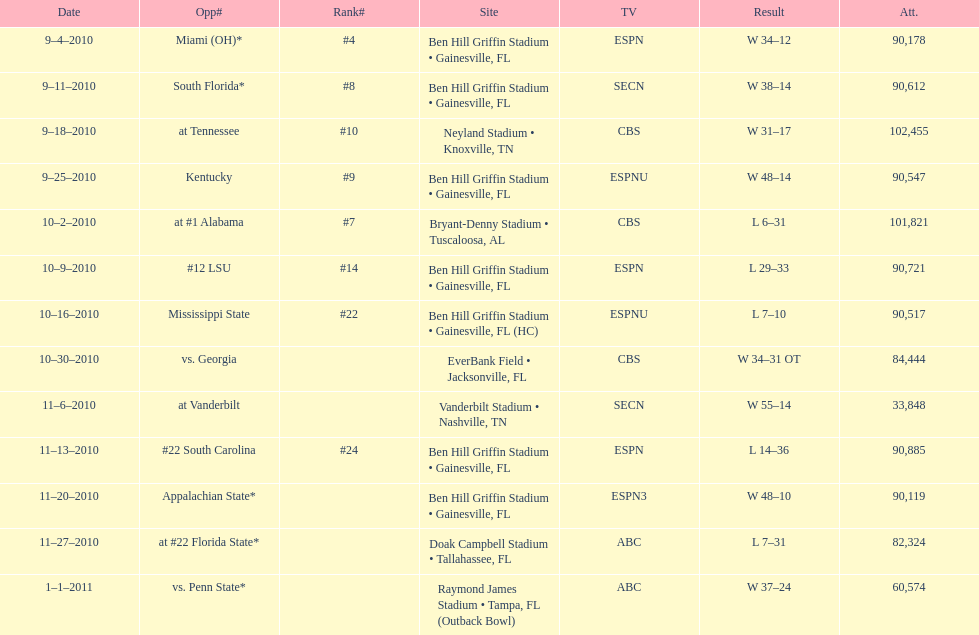The gators won the game on september 25, 2010. who won the previous game? Gators. 